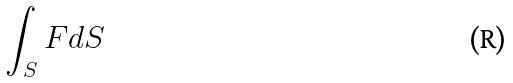Convert formula to latex. <formula><loc_0><loc_0><loc_500><loc_500>\int _ { S } F d S</formula> 